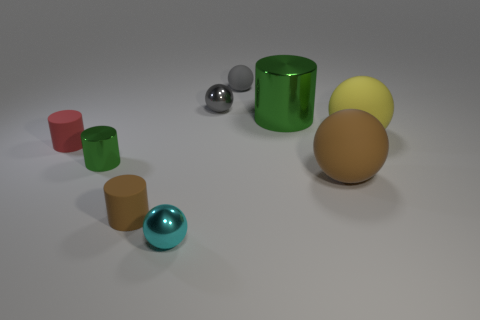Can you describe the lighting of the scene? Where might the light source be located? The lighting in the scene is soft and diffuse, suggesting an overhead source possibly out of view. The soft shadows under the objects indicate the light is coming from above and there isn't a harsh direct light, as there are no strong, hard-edged shadows. Does the lighting affect the colors of the objects? Yes, the soft lighting in the scene allows the true colors of the objects to come forth without strong alterations. However, the intensity and angle of the light source can affect our perception of color saturation and depth, potentially making the colors appear more muted or vivid. 